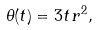<formula> <loc_0><loc_0><loc_500><loc_500>\theta ( t ) = 3 t \, r ^ { 2 } ,</formula> 